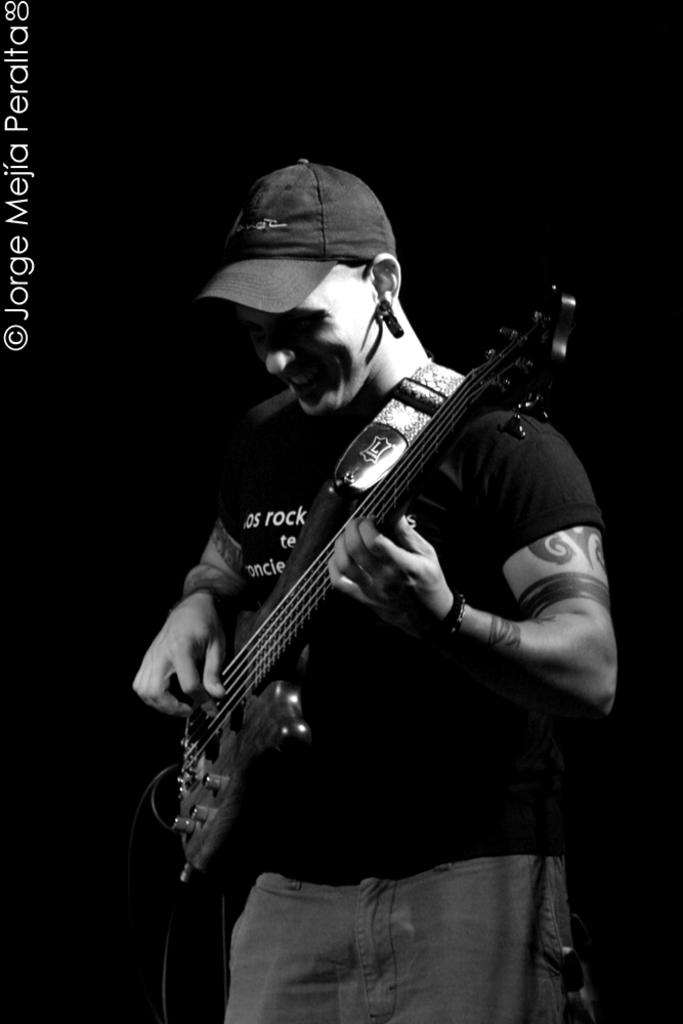What is the main subject of the image? The main subject of the image is a man. What is the man doing in the image? The man is standing and playing a guitar. What type of shoes is the man wearing on his toes in the image? The image does not show the man's toes or any shoes, so it is not possible to answer that question. 